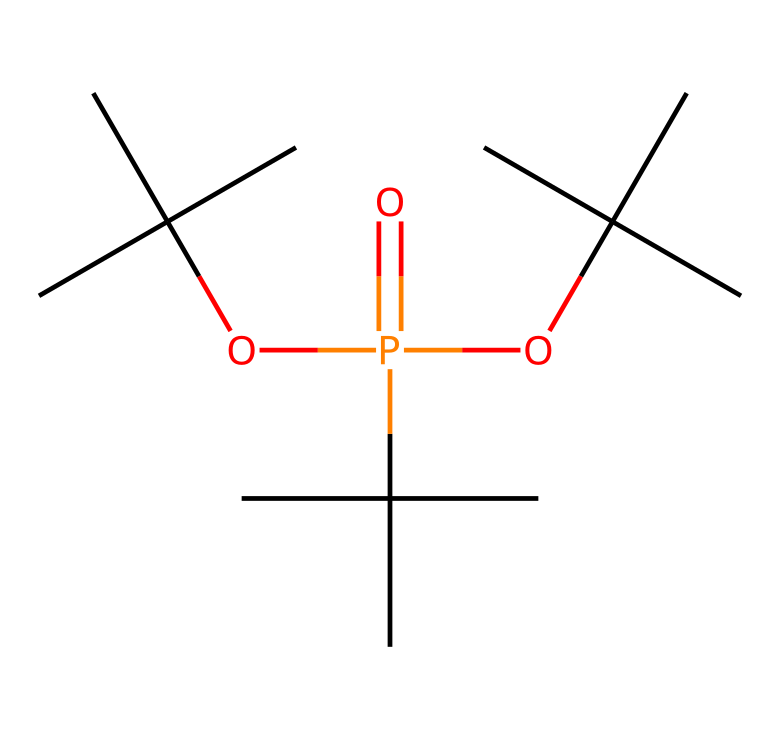What is the molecular formula of this compound? To determine the molecular formula, we need to count the number of each type of atom represented in the SMILES notation. The molecule contains 12 carbon atoms, 27 hydrogen atoms, and 1 phosphorus atom, and 4 oxygen atoms. Thus, the molecular formula is C12H27O4P.
Answer: C12H27O4P How many oxygen atoms are present in this compound? The SMILES notation includes "O" which represents oxygen. By counting the occurrences in the structure, we find that there are 4 oxygen atoms present in the compound.
Answer: 4 What type of phosphorus compound is this? The presence of organic groups and their structure suggests that this is an organophosphorus compound, specifically a phosphoric acid ester as indicated by the structure.
Answer: organophosphorus What is the main functional group in this molecule? The molecule contains phosphorus with oxygen atoms bonded to it, indicating a phosphate group (P=O and P–O–C linkages). This is characteristic of phosphoric acid esters.
Answer: phosphate What kind of bonding is likely present between phosphorus and oxygen in this compound? The structure indicates that phosphorus is bonded to oxygen through double bonds and single bonds, specifically P=O (double bond) and P–O (single bond). This suggests coordinate covalent bonding due to the electron-rich nature of the oxygen.
Answer: covalent What is the significance of such organophosphorus compounds in artifact conservation? Organophosphorus compounds like this one are often used in conservation due to their ability to bind and stabilize materials, protecting artifacts from degradation. Their chemical structure allows them to form protective layers.
Answer: artifact stabilization 